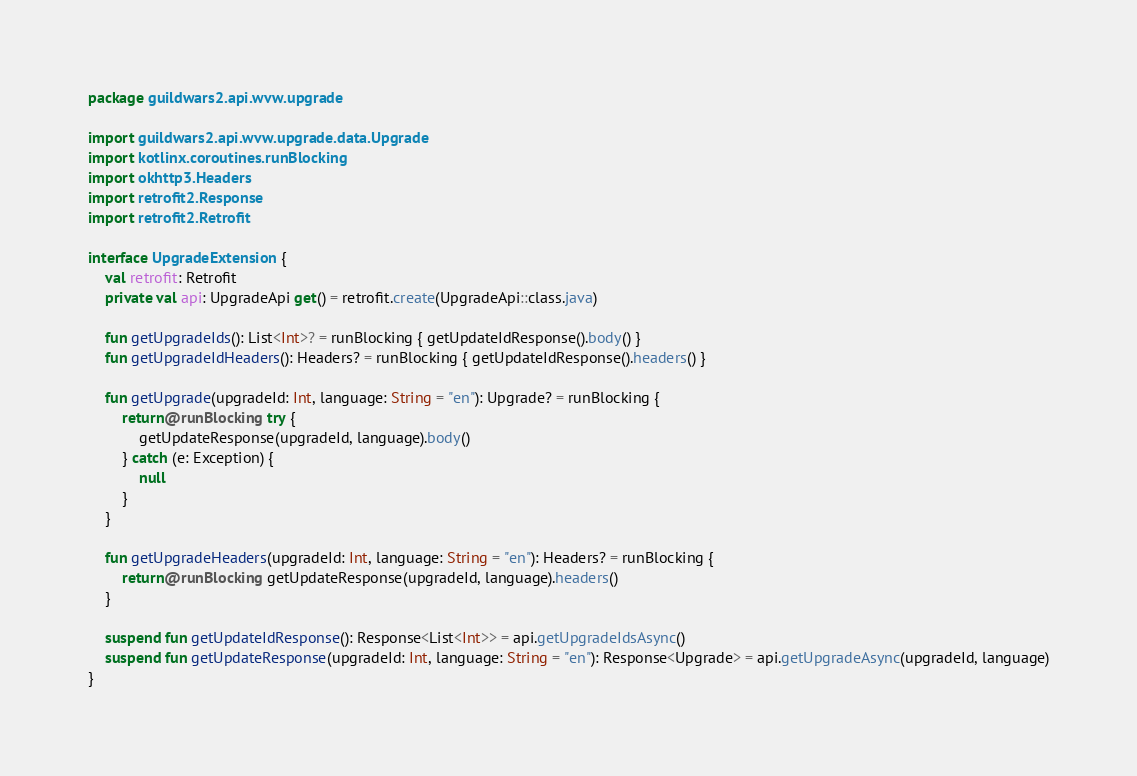Convert code to text. <code><loc_0><loc_0><loc_500><loc_500><_Kotlin_>package guildwars2.api.wvw.upgrade

import guildwars2.api.wvw.upgrade.data.Upgrade
import kotlinx.coroutines.runBlocking
import okhttp3.Headers
import retrofit2.Response
import retrofit2.Retrofit

interface UpgradeExtension {
    val retrofit: Retrofit
    private val api: UpgradeApi get() = retrofit.create(UpgradeApi::class.java)

    fun getUpgradeIds(): List<Int>? = runBlocking { getUpdateIdResponse().body() }
    fun getUpgradeIdHeaders(): Headers? = runBlocking { getUpdateIdResponse().headers() }

    fun getUpgrade(upgradeId: Int, language: String = "en"): Upgrade? = runBlocking {
        return@runBlocking try {
            getUpdateResponse(upgradeId, language).body()
        } catch (e: Exception) {
            null
        }
    }

    fun getUpgradeHeaders(upgradeId: Int, language: String = "en"): Headers? = runBlocking {
        return@runBlocking getUpdateResponse(upgradeId, language).headers()
    }

    suspend fun getUpdateIdResponse(): Response<List<Int>> = api.getUpgradeIdsAsync()
    suspend fun getUpdateResponse(upgradeId: Int, language: String = "en"): Response<Upgrade> = api.getUpgradeAsync(upgradeId, language)
}</code> 